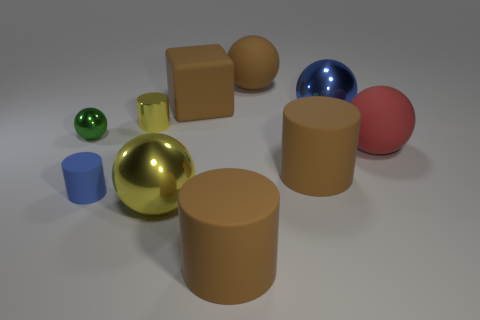Are the blue object that is in front of the small green shiny ball and the cube behind the green metal ball made of the same material?
Keep it short and to the point. Yes. There is a red thing that is the same size as the brown rubber block; what is its shape?
Your answer should be compact. Sphere. Is the number of blue spheres less than the number of large cyan spheres?
Keep it short and to the point. No. Is there a big thing that is right of the metallic thing that is in front of the big red thing?
Provide a succinct answer. Yes. Is there a metal thing in front of the yellow shiny object that is behind the rubber sphere in front of the small metallic sphere?
Your answer should be compact. Yes. There is a big matte thing that is right of the big blue shiny sphere; does it have the same shape as the small matte thing left of the red matte thing?
Keep it short and to the point. No. There is a small cylinder that is made of the same material as the small green sphere; what is its color?
Ensure brevity in your answer.  Yellow. Are there fewer yellow spheres behind the brown matte sphere than tiny gray shiny cubes?
Your response must be concise. No. There is a green sphere behind the big rubber cylinder that is on the right side of the brown cylinder that is left of the large brown rubber ball; what size is it?
Your answer should be compact. Small. Is the material of the cylinder that is behind the small green shiny sphere the same as the tiny sphere?
Provide a succinct answer. Yes. 